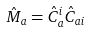<formula> <loc_0><loc_0><loc_500><loc_500>\hat { M } _ { a } = \hat { C } ^ { i } _ { a } \hat { C } _ { a i }</formula> 